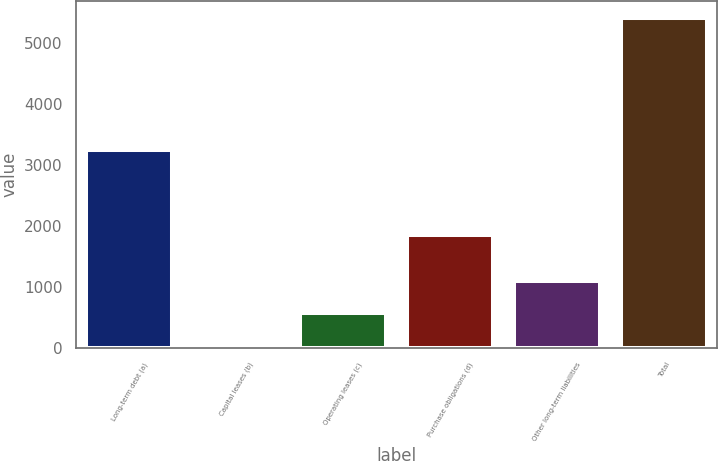Convert chart. <chart><loc_0><loc_0><loc_500><loc_500><bar_chart><fcel>Long-term debt (a)<fcel>Capital leases (b)<fcel>Operating leases (c)<fcel>Purchase obligations (d)<fcel>Other long-term liabilities<fcel>Total<nl><fcel>3251<fcel>27<fcel>566.3<fcel>1861<fcel>1105.6<fcel>5420<nl></chart> 